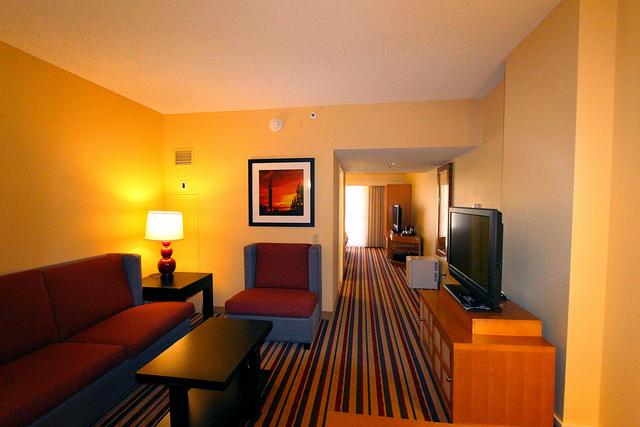Is the TV on the wall?
Short answer required. No. What color is the sofa?
Concise answer only. Red. Is the lamp on?
Answer briefly. Yes. 